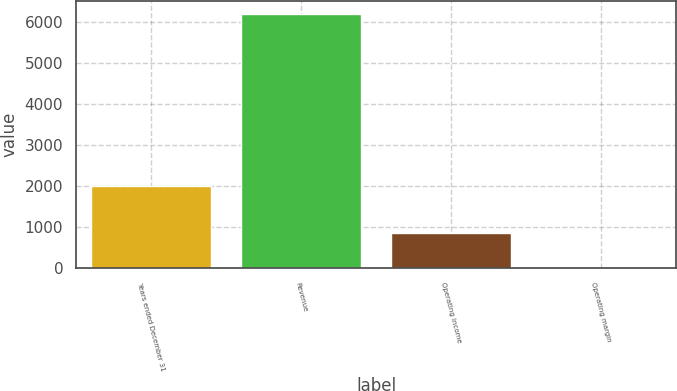<chart> <loc_0><loc_0><loc_500><loc_500><bar_chart><fcel>Years ended December 31<fcel>Revenue<fcel>Operating income<fcel>Operating margin<nl><fcel>2008<fcel>6197<fcel>846<fcel>13.7<nl></chart> 